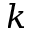Convert formula to latex. <formula><loc_0><loc_0><loc_500><loc_500>k</formula> 